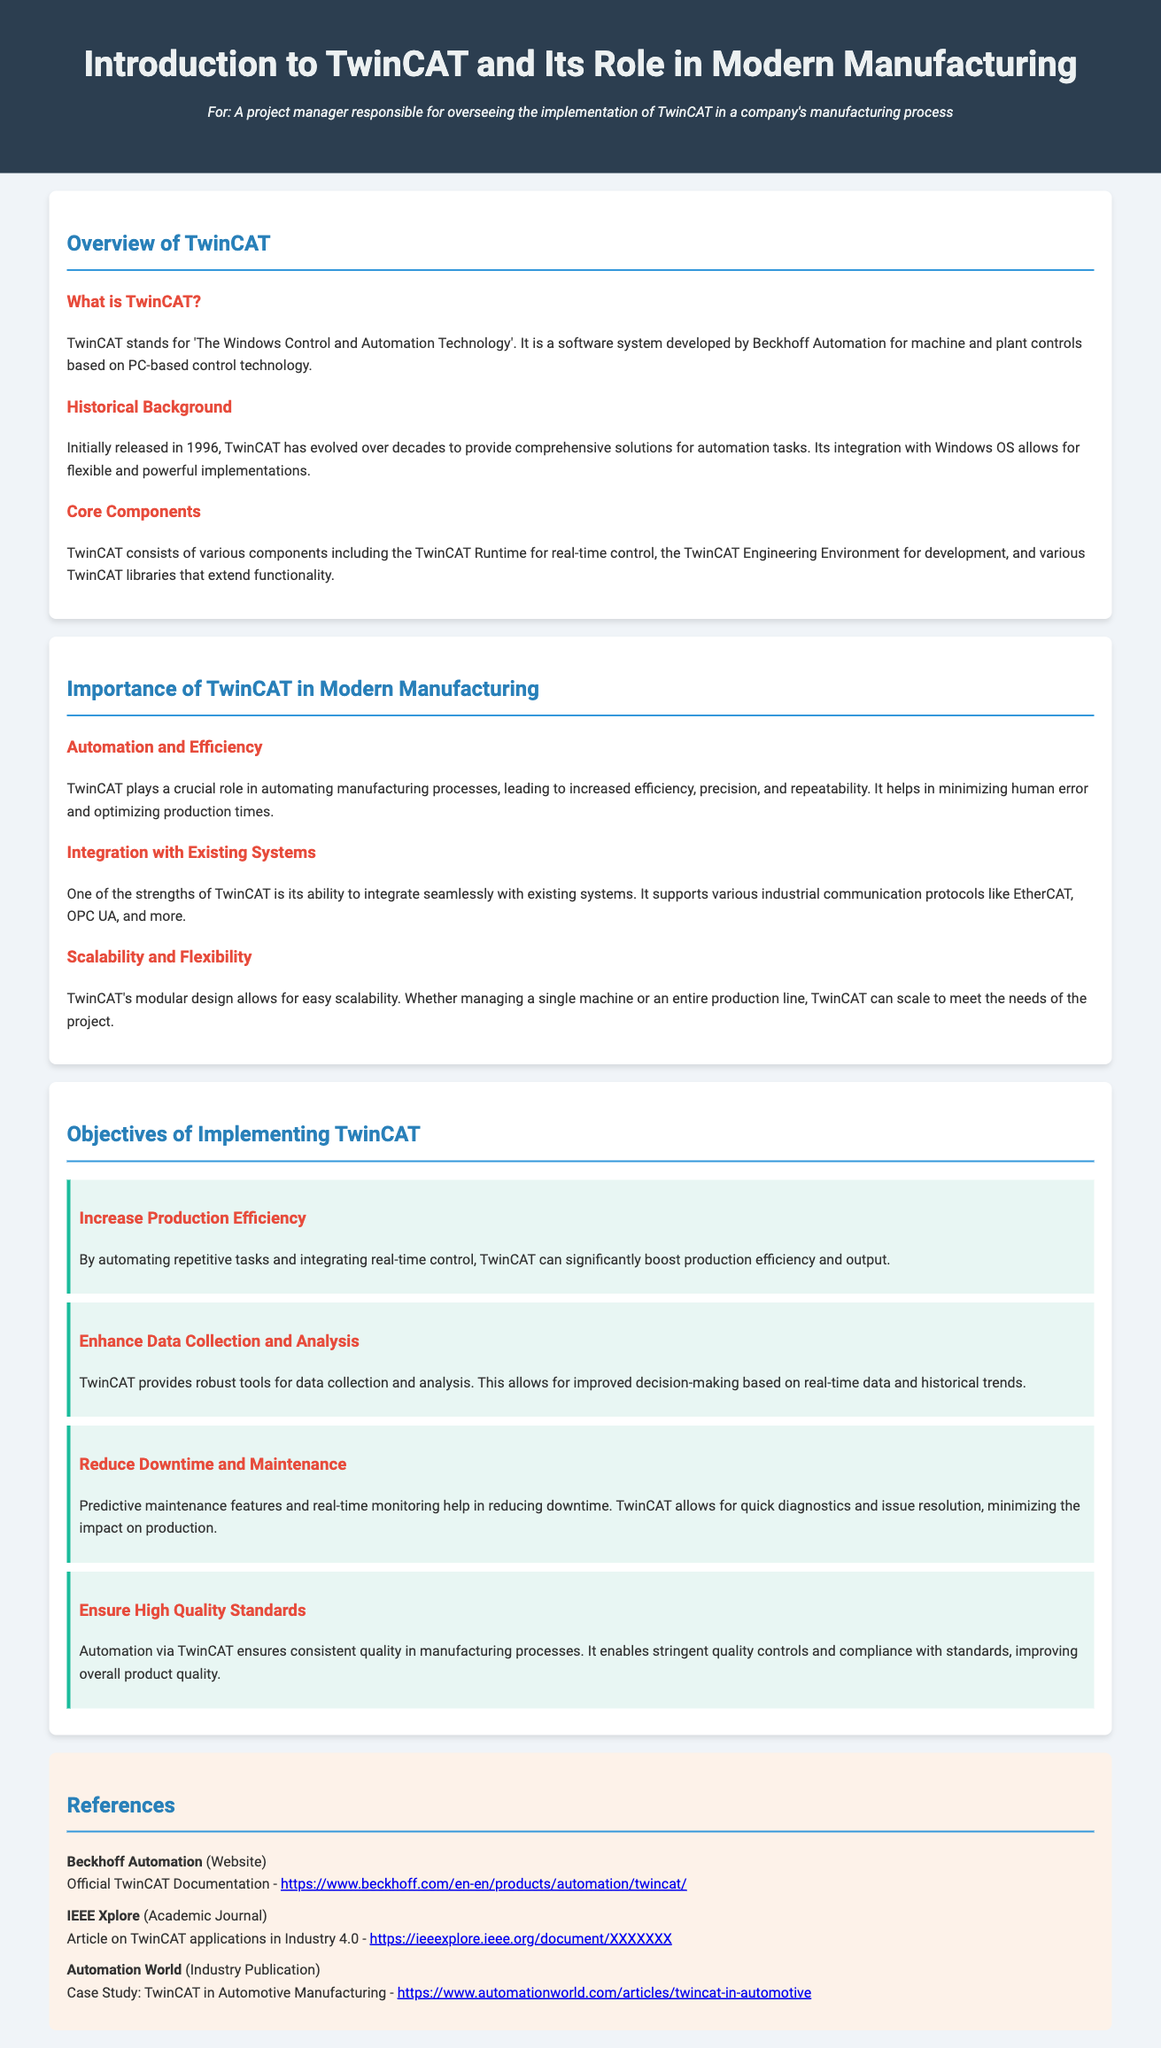What does TwinCAT stand for? TwinCAT stands for 'The Windows Control and Automation Technology'.
Answer: The Windows Control and Automation Technology When was TwinCAT initially released? TwinCAT was initially released in 1996.
Answer: 1996 What is one of the core components of TwinCAT? TwinCAT consists of various components including the TwinCAT Runtime for real-time control.
Answer: TwinCAT Runtime What is a key advantage of TwinCAT in manufacturing? TwinCAT helps in minimizing human error and optimizing production times.
Answer: Minimizing human error How does TwinCAT enhance data collection? TwinCAT provides robust tools for data collection and analysis.
Answer: Robust tools What is one objective of implementing TwinCAT? By automating repetitive tasks, TwinCAT can significantly boost production efficiency.
Answer: Boost production efficiency Which protocol does TwinCAT support for integration? TwinCAT supports various industrial communication protocols like EtherCAT.
Answer: EtherCAT What type of maintenance does TwinCAT help reduce? Predictive maintenance features help in reducing downtime.
Answer: Downtime What role does TwinCAT play in quality standards? It enables stringent quality controls and compliance with standards.
Answer: Stringent quality controls 